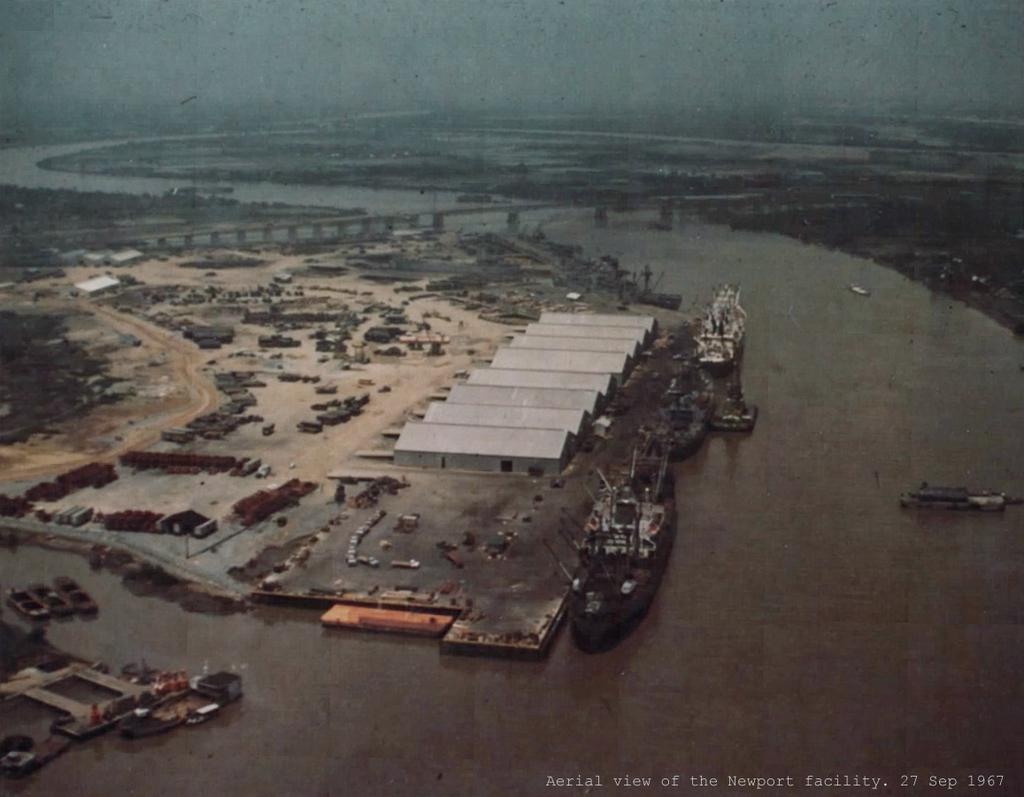What is in the water in the image? There are boats in the water in the image. What can be seen in the background of the image? There are objects, trees, and a bridge visible in the background. What is the color of the sky in the image? The sky is blue in color. What type of book is the beginner reading on the tin in the image? There is no book, beginner, or tin present in the image. 